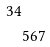Convert formula to latex. <formula><loc_0><loc_0><loc_500><loc_500>3 4 \\ & 5 6 7</formula> 